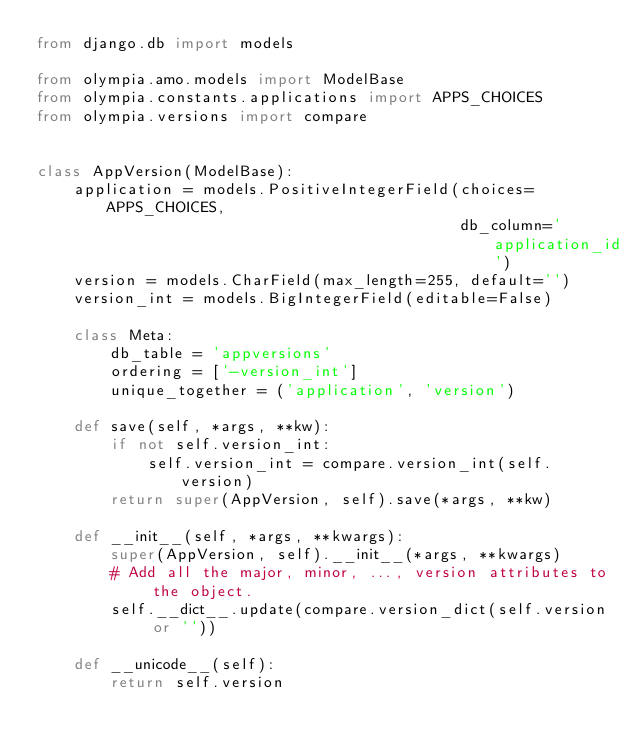<code> <loc_0><loc_0><loc_500><loc_500><_Python_>from django.db import models

from olympia.amo.models import ModelBase
from olympia.constants.applications import APPS_CHOICES
from olympia.versions import compare


class AppVersion(ModelBase):
    application = models.PositiveIntegerField(choices=APPS_CHOICES,
                                              db_column='application_id')
    version = models.CharField(max_length=255, default='')
    version_int = models.BigIntegerField(editable=False)

    class Meta:
        db_table = 'appversions'
        ordering = ['-version_int']
        unique_together = ('application', 'version')

    def save(self, *args, **kw):
        if not self.version_int:
            self.version_int = compare.version_int(self.version)
        return super(AppVersion, self).save(*args, **kw)

    def __init__(self, *args, **kwargs):
        super(AppVersion, self).__init__(*args, **kwargs)
        # Add all the major, minor, ..., version attributes to the object.
        self.__dict__.update(compare.version_dict(self.version or ''))

    def __unicode__(self):
        return self.version
</code> 